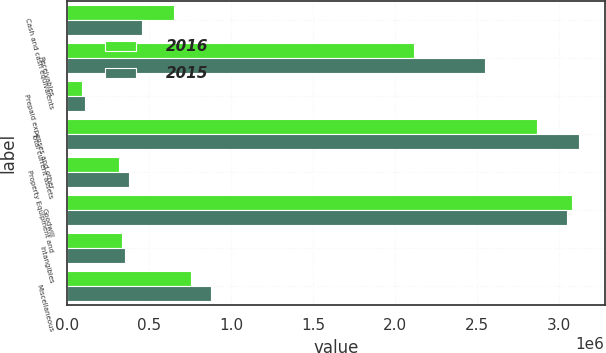Convert chart to OTSL. <chart><loc_0><loc_0><loc_500><loc_500><stacked_bar_chart><ecel><fcel>Cash and cash equivalents<fcel>Receivables<fcel>Prepaid expenses and other<fcel>Total current assets<fcel>Property Equipment and<fcel>Goodwill<fcel>Intangibles<fcel>Miscellaneous<nl><fcel>2016<fcel>655716<fcel>2.11566e+06<fcel>93091<fcel>2.86447e+06<fcel>319673<fcel>3.07963e+06<fcel>336922<fcel>759329<nl><fcel>2015<fcel>460859<fcel>2.54874e+06<fcel>113076<fcel>3.12268e+06<fcel>381238<fcel>3.04878e+06<fcel>353419<fcel>879813<nl></chart> 